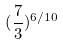Convert formula to latex. <formula><loc_0><loc_0><loc_500><loc_500>( \frac { 7 } { 3 } ) ^ { 6 / 1 0 }</formula> 